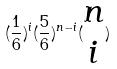<formula> <loc_0><loc_0><loc_500><loc_500>( \frac { 1 } { 6 } ) ^ { i } ( \frac { 5 } { 6 } ) ^ { n - i } ( \begin{matrix} n \\ i \end{matrix} )</formula> 